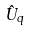Convert formula to latex. <formula><loc_0><loc_0><loc_500><loc_500>\hat { U } _ { q }</formula> 